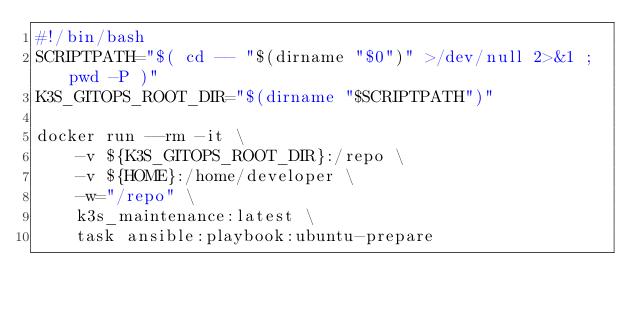<code> <loc_0><loc_0><loc_500><loc_500><_Bash_>#!/bin/bash
SCRIPTPATH="$( cd -- "$(dirname "$0")" >/dev/null 2>&1 ; pwd -P )"
K3S_GITOPS_ROOT_DIR="$(dirname "$SCRIPTPATH")"

docker run --rm -it \
    -v ${K3S_GITOPS_ROOT_DIR}:/repo \
    -v ${HOME}:/home/developer \
    -w="/repo" \
    k3s_maintenance:latest \
    task ansible:playbook:ubuntu-prepare
</code> 